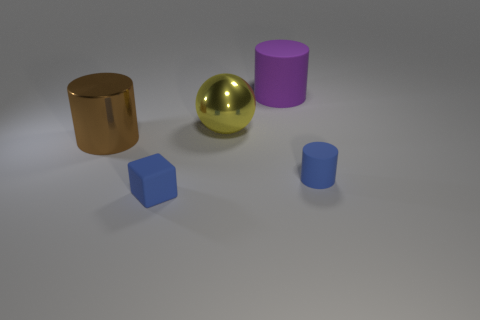There is a thing that is the same color as the small rubber cylinder; what is its material?
Ensure brevity in your answer.  Rubber. What number of cylinders are rubber things or large brown metallic objects?
Your response must be concise. 3. There is a blue object that is on the left side of the blue object behind the blue block; what is its shape?
Your answer should be very brief. Cube. There is a blue thing on the left side of the matte cylinder behind the cylinder that is to the right of the large purple matte thing; what size is it?
Your response must be concise. Small. Does the purple cylinder have the same size as the brown thing?
Your answer should be compact. Yes. How many objects are either big brown things or yellow blocks?
Provide a succinct answer. 1. What size is the thing that is in front of the small object right of the large rubber cylinder?
Ensure brevity in your answer.  Small. How big is the matte cube?
Your answer should be very brief. Small. What shape is the object that is both to the left of the purple cylinder and in front of the brown shiny cylinder?
Ensure brevity in your answer.  Cube. What color is the other small object that is the same shape as the brown object?
Keep it short and to the point. Blue. 